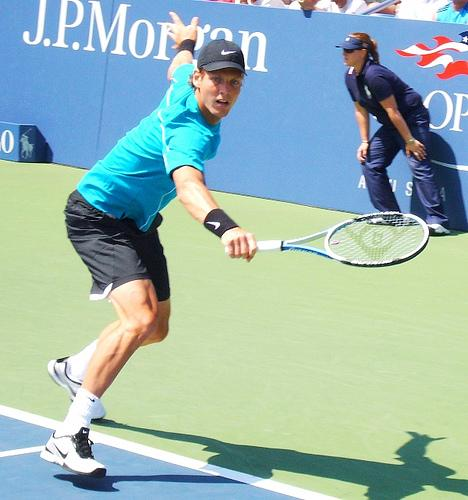What type of stroke is being used? backhand 